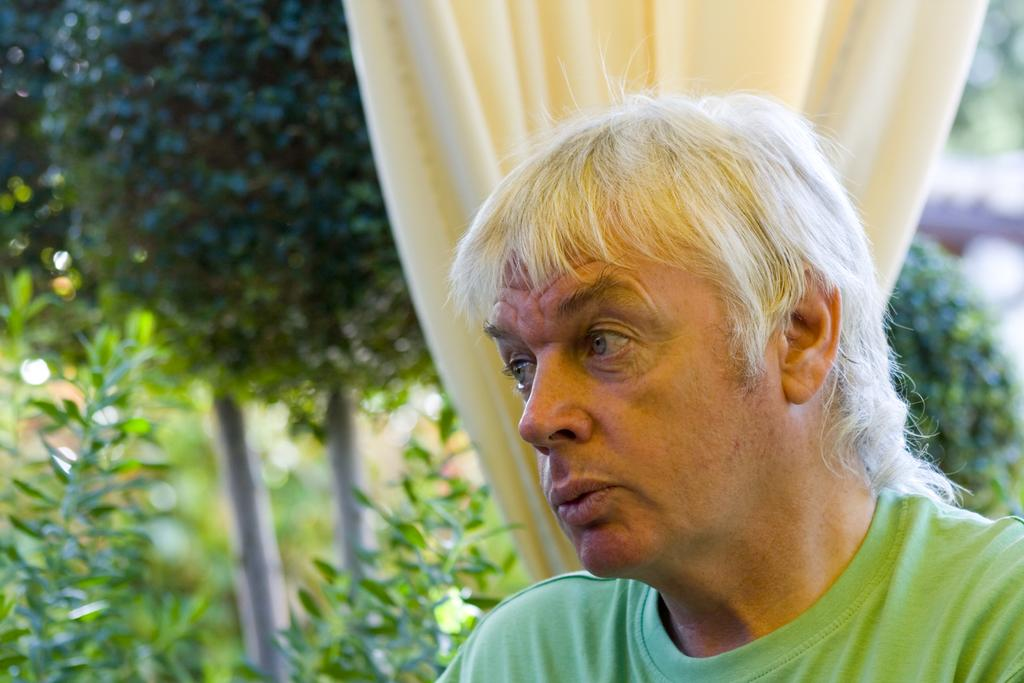Who is present in the image? There is a man in the image. What is the man wearing? The man is wearing a green t-shirt. What can be seen in the background of the image? There is a curtain and trees visible in the background of the image. What type of cushion is being used to create the mist in the image? There is no mist or cushion present in the image. 